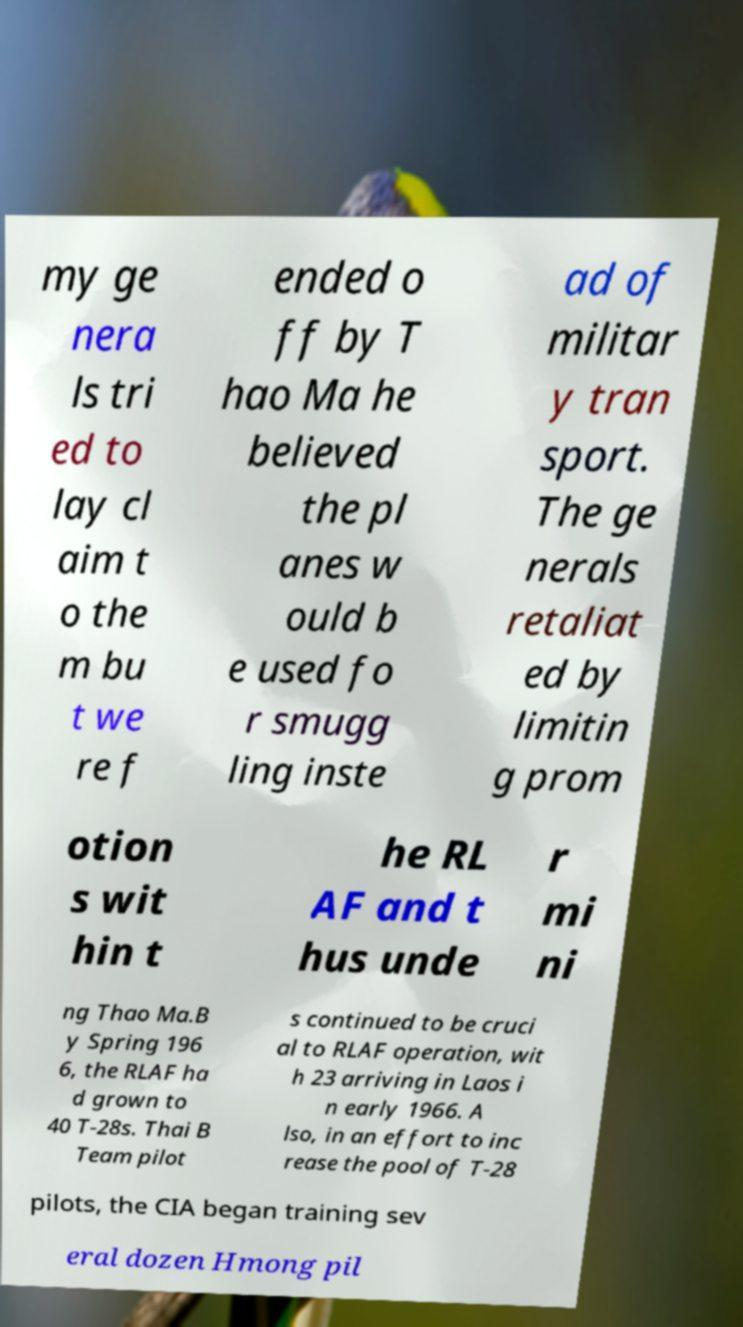What messages or text are displayed in this image? I need them in a readable, typed format. my ge nera ls tri ed to lay cl aim t o the m bu t we re f ended o ff by T hao Ma he believed the pl anes w ould b e used fo r smugg ling inste ad of militar y tran sport. The ge nerals retaliat ed by limitin g prom otion s wit hin t he RL AF and t hus unde r mi ni ng Thao Ma.B y Spring 196 6, the RLAF ha d grown to 40 T-28s. Thai B Team pilot s continued to be cruci al to RLAF operation, wit h 23 arriving in Laos i n early 1966. A lso, in an effort to inc rease the pool of T-28 pilots, the CIA began training sev eral dozen Hmong pil 